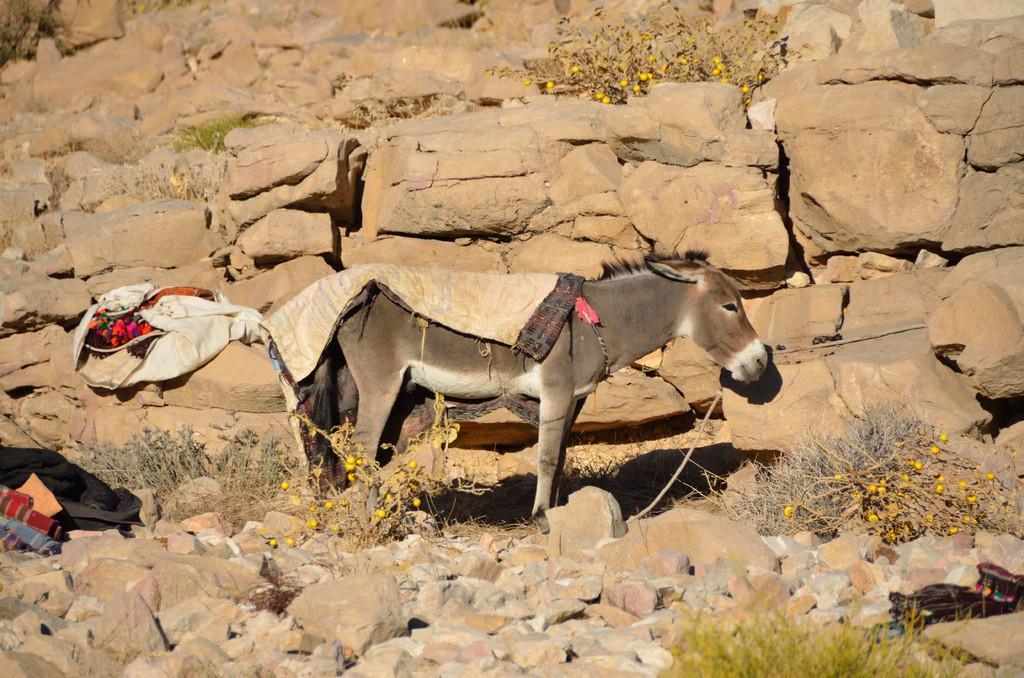How would you summarize this image in a sentence or two? This picture is clicked outside the city. In the center there is a donkey standing on the ground and we can see the stones, plants and some other objects. 